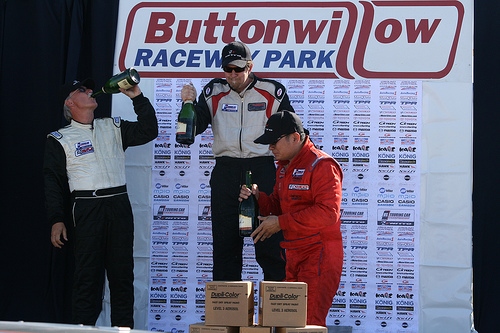<image>
Can you confirm if the man is on the man? Yes. Looking at the image, I can see the man is positioned on top of the man, with the man providing support. 